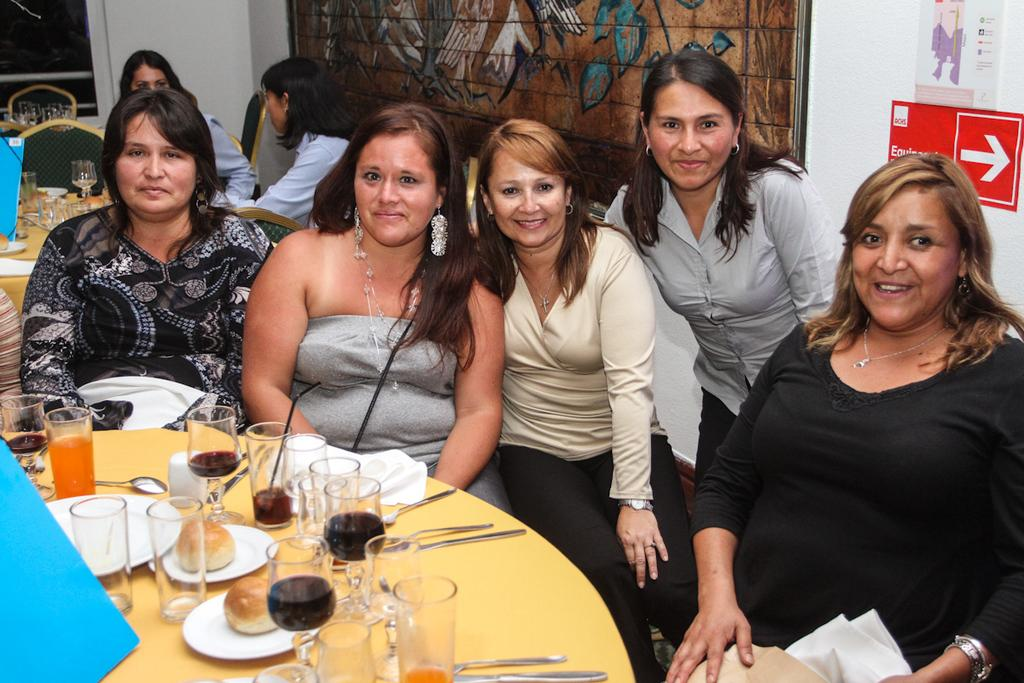What are the women in the image doing? The women are sitting on chairs in the image. What is in front of the women? There is a table in front of the women. What can be seen on the table? There is a wine glass, a spoon, plates, a bun, and a fork on the table. Can you tell me how many zebras are present in the image? There are no zebras present in the image. What type of watch is the woman wearing in the image? There is no watch visible on any of the women in the image. 